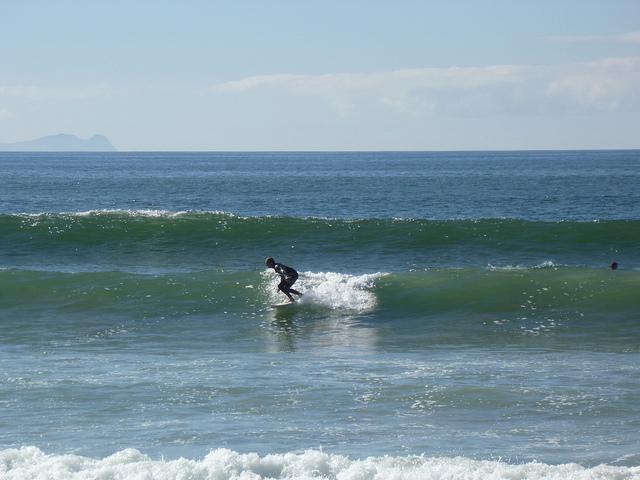How many people are in the water?
Give a very brief answer. 2. How many waves are breaking?
Give a very brief answer. 2. How many pizzas are cooked in the picture?
Give a very brief answer. 0. 